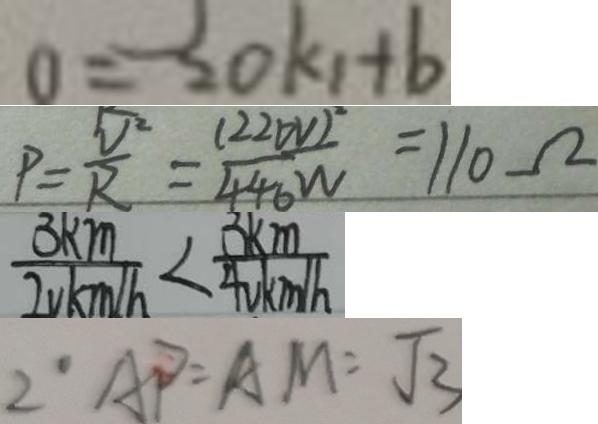Convert formula to latex. <formula><loc_0><loc_0><loc_500><loc_500>0 = 2 0 k _ { 1 } + b 
 P = \frac { V ^ { 2 } } { R } = \frac { ( 2 2 0 V ) ^ { 2 } } { 4 4 0 W } = 1 1 0 \Omega 
 \frac { 3 k m } { 2 v k m / h } < \frac { 3 k m } { 4 v k m / h } 
 2 \cdot A P = A M = \sqrt { 3 }</formula> 